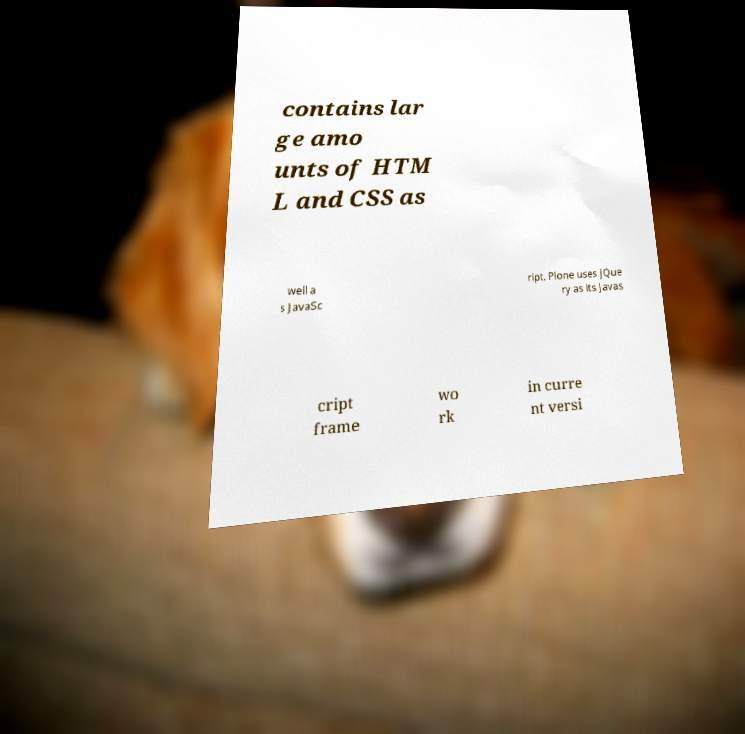Please read and relay the text visible in this image. What does it say? contains lar ge amo unts of HTM L and CSS as well a s JavaSc ript. Plone uses jQue ry as its Javas cript frame wo rk in curre nt versi 